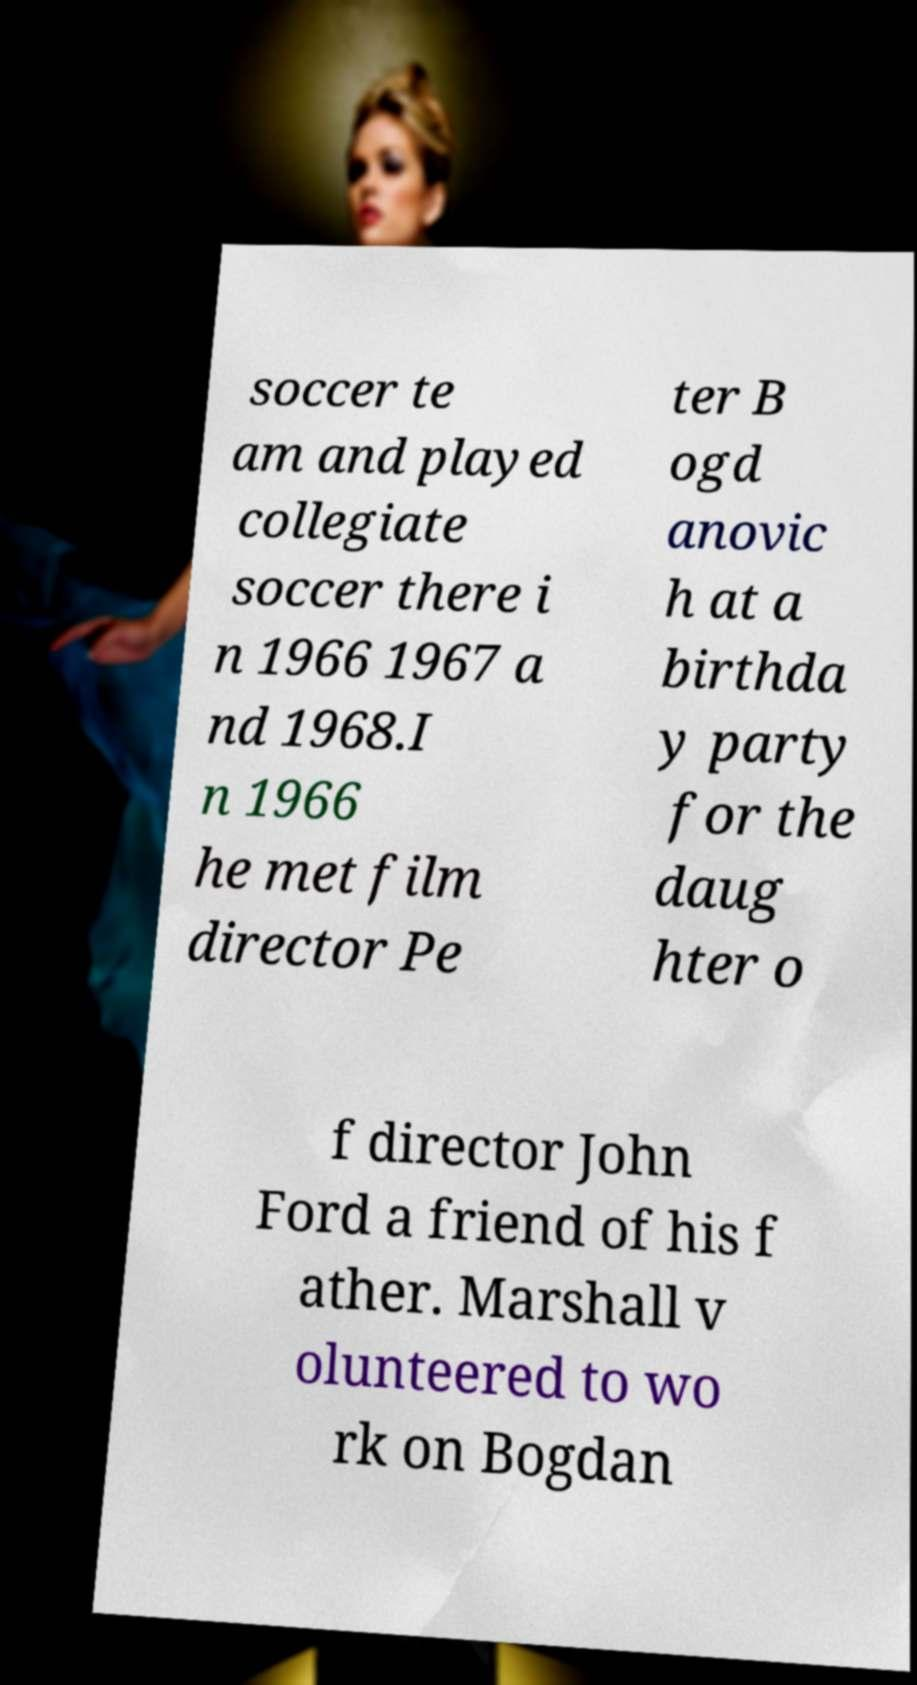For documentation purposes, I need the text within this image transcribed. Could you provide that? soccer te am and played collegiate soccer there i n 1966 1967 a nd 1968.I n 1966 he met film director Pe ter B ogd anovic h at a birthda y party for the daug hter o f director John Ford a friend of his f ather. Marshall v olunteered to wo rk on Bogdan 